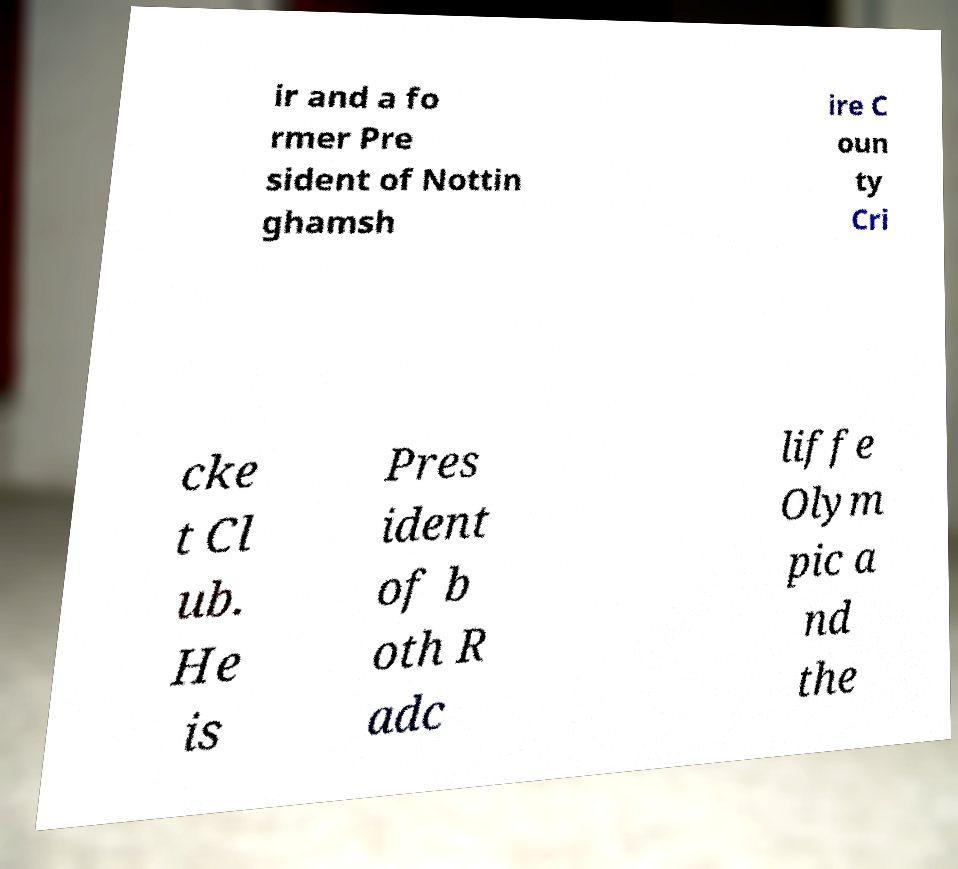Please identify and transcribe the text found in this image. ir and a fo rmer Pre sident of Nottin ghamsh ire C oun ty Cri cke t Cl ub. He is Pres ident of b oth R adc liffe Olym pic a nd the 